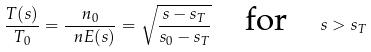Convert formula to latex. <formula><loc_0><loc_0><loc_500><loc_500>\frac { T ( s ) } { T _ { 0 } } = \frac { n _ { 0 } } { \ n E ( s ) } = \sqrt { \frac { s - s _ { T } } { s _ { 0 } - s _ { T } } } \quad \text {for} \quad s > s _ { T }</formula> 